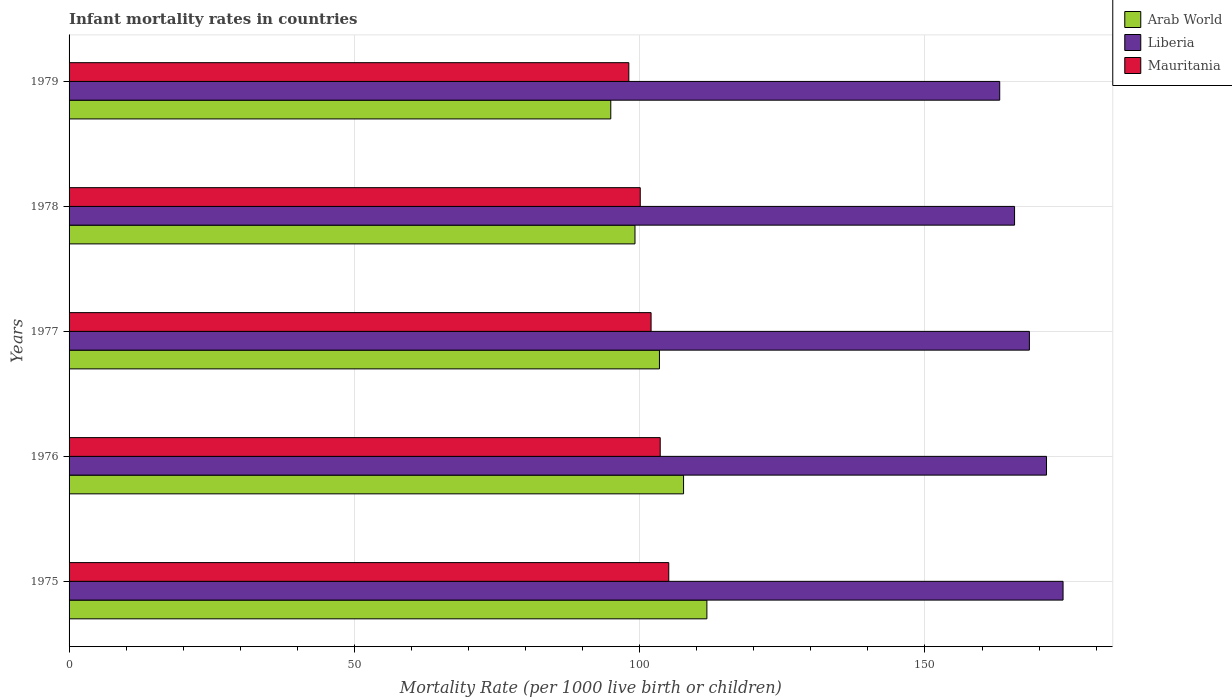How many groups of bars are there?
Keep it short and to the point. 5. Are the number of bars per tick equal to the number of legend labels?
Provide a short and direct response. Yes. What is the label of the 1st group of bars from the top?
Provide a short and direct response. 1979. In how many cases, is the number of bars for a given year not equal to the number of legend labels?
Your response must be concise. 0. What is the infant mortality rate in Arab World in 1979?
Give a very brief answer. 94.94. Across all years, what is the maximum infant mortality rate in Liberia?
Provide a short and direct response. 174.2. Across all years, what is the minimum infant mortality rate in Mauritania?
Ensure brevity in your answer.  98.1. In which year was the infant mortality rate in Mauritania maximum?
Give a very brief answer. 1975. In which year was the infant mortality rate in Arab World minimum?
Keep it short and to the point. 1979. What is the total infant mortality rate in Mauritania in the graph?
Make the answer very short. 508.9. What is the difference between the infant mortality rate in Mauritania in 1977 and that in 1978?
Provide a succinct answer. 1.9. What is the difference between the infant mortality rate in Liberia in 1977 and the infant mortality rate in Mauritania in 1976?
Provide a short and direct response. 64.7. What is the average infant mortality rate in Liberia per year?
Provide a short and direct response. 168.52. In the year 1977, what is the difference between the infant mortality rate in Mauritania and infant mortality rate in Liberia?
Offer a very short reply. -66.3. In how many years, is the infant mortality rate in Arab World greater than 170 ?
Provide a succinct answer. 0. What is the ratio of the infant mortality rate in Arab World in 1975 to that in 1978?
Provide a succinct answer. 1.13. What is the difference between the highest and the second highest infant mortality rate in Arab World?
Make the answer very short. 4.09. What is the difference between the highest and the lowest infant mortality rate in Liberia?
Provide a succinct answer. 11.1. Is the sum of the infant mortality rate in Liberia in 1975 and 1977 greater than the maximum infant mortality rate in Mauritania across all years?
Provide a succinct answer. Yes. What does the 2nd bar from the top in 1976 represents?
Your answer should be very brief. Liberia. What does the 1st bar from the bottom in 1979 represents?
Your response must be concise. Arab World. How many bars are there?
Offer a terse response. 15. What is the difference between two consecutive major ticks on the X-axis?
Provide a short and direct response. 50. Are the values on the major ticks of X-axis written in scientific E-notation?
Offer a very short reply. No. Does the graph contain any zero values?
Your answer should be compact. No. Does the graph contain grids?
Your answer should be very brief. Yes. What is the title of the graph?
Ensure brevity in your answer.  Infant mortality rates in countries. What is the label or title of the X-axis?
Provide a short and direct response. Mortality Rate (per 1000 live birth or children). What is the label or title of the Y-axis?
Provide a short and direct response. Years. What is the Mortality Rate (per 1000 live birth or children) in Arab World in 1975?
Offer a terse response. 111.78. What is the Mortality Rate (per 1000 live birth or children) of Liberia in 1975?
Ensure brevity in your answer.  174.2. What is the Mortality Rate (per 1000 live birth or children) in Mauritania in 1975?
Provide a succinct answer. 105.1. What is the Mortality Rate (per 1000 live birth or children) of Arab World in 1976?
Provide a succinct answer. 107.69. What is the Mortality Rate (per 1000 live birth or children) of Liberia in 1976?
Offer a terse response. 171.3. What is the Mortality Rate (per 1000 live birth or children) in Mauritania in 1976?
Your answer should be very brief. 103.6. What is the Mortality Rate (per 1000 live birth or children) of Arab World in 1977?
Ensure brevity in your answer.  103.47. What is the Mortality Rate (per 1000 live birth or children) of Liberia in 1977?
Make the answer very short. 168.3. What is the Mortality Rate (per 1000 live birth or children) of Mauritania in 1977?
Give a very brief answer. 102. What is the Mortality Rate (per 1000 live birth or children) in Arab World in 1978?
Keep it short and to the point. 99.18. What is the Mortality Rate (per 1000 live birth or children) in Liberia in 1978?
Give a very brief answer. 165.7. What is the Mortality Rate (per 1000 live birth or children) in Mauritania in 1978?
Provide a short and direct response. 100.1. What is the Mortality Rate (per 1000 live birth or children) in Arab World in 1979?
Make the answer very short. 94.94. What is the Mortality Rate (per 1000 live birth or children) of Liberia in 1979?
Offer a very short reply. 163.1. What is the Mortality Rate (per 1000 live birth or children) in Mauritania in 1979?
Make the answer very short. 98.1. Across all years, what is the maximum Mortality Rate (per 1000 live birth or children) of Arab World?
Give a very brief answer. 111.78. Across all years, what is the maximum Mortality Rate (per 1000 live birth or children) of Liberia?
Your answer should be compact. 174.2. Across all years, what is the maximum Mortality Rate (per 1000 live birth or children) of Mauritania?
Make the answer very short. 105.1. Across all years, what is the minimum Mortality Rate (per 1000 live birth or children) in Arab World?
Your response must be concise. 94.94. Across all years, what is the minimum Mortality Rate (per 1000 live birth or children) in Liberia?
Your response must be concise. 163.1. Across all years, what is the minimum Mortality Rate (per 1000 live birth or children) of Mauritania?
Keep it short and to the point. 98.1. What is the total Mortality Rate (per 1000 live birth or children) of Arab World in the graph?
Offer a terse response. 517.05. What is the total Mortality Rate (per 1000 live birth or children) in Liberia in the graph?
Provide a short and direct response. 842.6. What is the total Mortality Rate (per 1000 live birth or children) in Mauritania in the graph?
Offer a terse response. 508.9. What is the difference between the Mortality Rate (per 1000 live birth or children) in Arab World in 1975 and that in 1976?
Your answer should be compact. 4.09. What is the difference between the Mortality Rate (per 1000 live birth or children) of Mauritania in 1975 and that in 1976?
Offer a terse response. 1.5. What is the difference between the Mortality Rate (per 1000 live birth or children) in Arab World in 1975 and that in 1977?
Provide a short and direct response. 8.31. What is the difference between the Mortality Rate (per 1000 live birth or children) of Liberia in 1975 and that in 1977?
Your answer should be compact. 5.9. What is the difference between the Mortality Rate (per 1000 live birth or children) of Mauritania in 1975 and that in 1977?
Give a very brief answer. 3.1. What is the difference between the Mortality Rate (per 1000 live birth or children) in Arab World in 1975 and that in 1978?
Your response must be concise. 12.6. What is the difference between the Mortality Rate (per 1000 live birth or children) of Liberia in 1975 and that in 1978?
Provide a succinct answer. 8.5. What is the difference between the Mortality Rate (per 1000 live birth or children) in Mauritania in 1975 and that in 1978?
Provide a succinct answer. 5. What is the difference between the Mortality Rate (per 1000 live birth or children) in Arab World in 1975 and that in 1979?
Your answer should be very brief. 16.84. What is the difference between the Mortality Rate (per 1000 live birth or children) in Arab World in 1976 and that in 1977?
Provide a short and direct response. 4.23. What is the difference between the Mortality Rate (per 1000 live birth or children) in Liberia in 1976 and that in 1977?
Provide a succinct answer. 3. What is the difference between the Mortality Rate (per 1000 live birth or children) of Mauritania in 1976 and that in 1977?
Offer a terse response. 1.6. What is the difference between the Mortality Rate (per 1000 live birth or children) of Arab World in 1976 and that in 1978?
Make the answer very short. 8.51. What is the difference between the Mortality Rate (per 1000 live birth or children) in Liberia in 1976 and that in 1978?
Your answer should be very brief. 5.6. What is the difference between the Mortality Rate (per 1000 live birth or children) of Arab World in 1976 and that in 1979?
Keep it short and to the point. 12.76. What is the difference between the Mortality Rate (per 1000 live birth or children) of Liberia in 1976 and that in 1979?
Provide a short and direct response. 8.2. What is the difference between the Mortality Rate (per 1000 live birth or children) in Mauritania in 1976 and that in 1979?
Your answer should be compact. 5.5. What is the difference between the Mortality Rate (per 1000 live birth or children) of Arab World in 1977 and that in 1978?
Your answer should be very brief. 4.29. What is the difference between the Mortality Rate (per 1000 live birth or children) of Arab World in 1977 and that in 1979?
Your answer should be compact. 8.53. What is the difference between the Mortality Rate (per 1000 live birth or children) of Liberia in 1977 and that in 1979?
Your answer should be compact. 5.2. What is the difference between the Mortality Rate (per 1000 live birth or children) in Arab World in 1978 and that in 1979?
Make the answer very short. 4.24. What is the difference between the Mortality Rate (per 1000 live birth or children) of Liberia in 1978 and that in 1979?
Your response must be concise. 2.6. What is the difference between the Mortality Rate (per 1000 live birth or children) of Mauritania in 1978 and that in 1979?
Ensure brevity in your answer.  2. What is the difference between the Mortality Rate (per 1000 live birth or children) in Arab World in 1975 and the Mortality Rate (per 1000 live birth or children) in Liberia in 1976?
Your response must be concise. -59.52. What is the difference between the Mortality Rate (per 1000 live birth or children) in Arab World in 1975 and the Mortality Rate (per 1000 live birth or children) in Mauritania in 1976?
Keep it short and to the point. 8.18. What is the difference between the Mortality Rate (per 1000 live birth or children) in Liberia in 1975 and the Mortality Rate (per 1000 live birth or children) in Mauritania in 1976?
Offer a very short reply. 70.6. What is the difference between the Mortality Rate (per 1000 live birth or children) of Arab World in 1975 and the Mortality Rate (per 1000 live birth or children) of Liberia in 1977?
Provide a short and direct response. -56.52. What is the difference between the Mortality Rate (per 1000 live birth or children) of Arab World in 1975 and the Mortality Rate (per 1000 live birth or children) of Mauritania in 1977?
Offer a very short reply. 9.78. What is the difference between the Mortality Rate (per 1000 live birth or children) of Liberia in 1975 and the Mortality Rate (per 1000 live birth or children) of Mauritania in 1977?
Your answer should be compact. 72.2. What is the difference between the Mortality Rate (per 1000 live birth or children) in Arab World in 1975 and the Mortality Rate (per 1000 live birth or children) in Liberia in 1978?
Provide a short and direct response. -53.92. What is the difference between the Mortality Rate (per 1000 live birth or children) of Arab World in 1975 and the Mortality Rate (per 1000 live birth or children) of Mauritania in 1978?
Ensure brevity in your answer.  11.68. What is the difference between the Mortality Rate (per 1000 live birth or children) of Liberia in 1975 and the Mortality Rate (per 1000 live birth or children) of Mauritania in 1978?
Your response must be concise. 74.1. What is the difference between the Mortality Rate (per 1000 live birth or children) of Arab World in 1975 and the Mortality Rate (per 1000 live birth or children) of Liberia in 1979?
Ensure brevity in your answer.  -51.32. What is the difference between the Mortality Rate (per 1000 live birth or children) of Arab World in 1975 and the Mortality Rate (per 1000 live birth or children) of Mauritania in 1979?
Offer a terse response. 13.68. What is the difference between the Mortality Rate (per 1000 live birth or children) of Liberia in 1975 and the Mortality Rate (per 1000 live birth or children) of Mauritania in 1979?
Offer a very short reply. 76.1. What is the difference between the Mortality Rate (per 1000 live birth or children) of Arab World in 1976 and the Mortality Rate (per 1000 live birth or children) of Liberia in 1977?
Offer a very short reply. -60.61. What is the difference between the Mortality Rate (per 1000 live birth or children) of Arab World in 1976 and the Mortality Rate (per 1000 live birth or children) of Mauritania in 1977?
Provide a short and direct response. 5.69. What is the difference between the Mortality Rate (per 1000 live birth or children) of Liberia in 1976 and the Mortality Rate (per 1000 live birth or children) of Mauritania in 1977?
Provide a short and direct response. 69.3. What is the difference between the Mortality Rate (per 1000 live birth or children) in Arab World in 1976 and the Mortality Rate (per 1000 live birth or children) in Liberia in 1978?
Make the answer very short. -58.01. What is the difference between the Mortality Rate (per 1000 live birth or children) of Arab World in 1976 and the Mortality Rate (per 1000 live birth or children) of Mauritania in 1978?
Ensure brevity in your answer.  7.59. What is the difference between the Mortality Rate (per 1000 live birth or children) in Liberia in 1976 and the Mortality Rate (per 1000 live birth or children) in Mauritania in 1978?
Keep it short and to the point. 71.2. What is the difference between the Mortality Rate (per 1000 live birth or children) of Arab World in 1976 and the Mortality Rate (per 1000 live birth or children) of Liberia in 1979?
Ensure brevity in your answer.  -55.41. What is the difference between the Mortality Rate (per 1000 live birth or children) of Arab World in 1976 and the Mortality Rate (per 1000 live birth or children) of Mauritania in 1979?
Your answer should be compact. 9.59. What is the difference between the Mortality Rate (per 1000 live birth or children) in Liberia in 1976 and the Mortality Rate (per 1000 live birth or children) in Mauritania in 1979?
Your answer should be very brief. 73.2. What is the difference between the Mortality Rate (per 1000 live birth or children) of Arab World in 1977 and the Mortality Rate (per 1000 live birth or children) of Liberia in 1978?
Provide a succinct answer. -62.23. What is the difference between the Mortality Rate (per 1000 live birth or children) in Arab World in 1977 and the Mortality Rate (per 1000 live birth or children) in Mauritania in 1978?
Make the answer very short. 3.37. What is the difference between the Mortality Rate (per 1000 live birth or children) in Liberia in 1977 and the Mortality Rate (per 1000 live birth or children) in Mauritania in 1978?
Provide a succinct answer. 68.2. What is the difference between the Mortality Rate (per 1000 live birth or children) in Arab World in 1977 and the Mortality Rate (per 1000 live birth or children) in Liberia in 1979?
Offer a terse response. -59.63. What is the difference between the Mortality Rate (per 1000 live birth or children) of Arab World in 1977 and the Mortality Rate (per 1000 live birth or children) of Mauritania in 1979?
Ensure brevity in your answer.  5.37. What is the difference between the Mortality Rate (per 1000 live birth or children) of Liberia in 1977 and the Mortality Rate (per 1000 live birth or children) of Mauritania in 1979?
Give a very brief answer. 70.2. What is the difference between the Mortality Rate (per 1000 live birth or children) in Arab World in 1978 and the Mortality Rate (per 1000 live birth or children) in Liberia in 1979?
Offer a terse response. -63.92. What is the difference between the Mortality Rate (per 1000 live birth or children) in Arab World in 1978 and the Mortality Rate (per 1000 live birth or children) in Mauritania in 1979?
Your answer should be compact. 1.08. What is the difference between the Mortality Rate (per 1000 live birth or children) in Liberia in 1978 and the Mortality Rate (per 1000 live birth or children) in Mauritania in 1979?
Your answer should be very brief. 67.6. What is the average Mortality Rate (per 1000 live birth or children) in Arab World per year?
Your answer should be compact. 103.41. What is the average Mortality Rate (per 1000 live birth or children) of Liberia per year?
Provide a succinct answer. 168.52. What is the average Mortality Rate (per 1000 live birth or children) of Mauritania per year?
Keep it short and to the point. 101.78. In the year 1975, what is the difference between the Mortality Rate (per 1000 live birth or children) in Arab World and Mortality Rate (per 1000 live birth or children) in Liberia?
Offer a terse response. -62.42. In the year 1975, what is the difference between the Mortality Rate (per 1000 live birth or children) in Arab World and Mortality Rate (per 1000 live birth or children) in Mauritania?
Keep it short and to the point. 6.68. In the year 1975, what is the difference between the Mortality Rate (per 1000 live birth or children) in Liberia and Mortality Rate (per 1000 live birth or children) in Mauritania?
Offer a terse response. 69.1. In the year 1976, what is the difference between the Mortality Rate (per 1000 live birth or children) of Arab World and Mortality Rate (per 1000 live birth or children) of Liberia?
Give a very brief answer. -63.61. In the year 1976, what is the difference between the Mortality Rate (per 1000 live birth or children) in Arab World and Mortality Rate (per 1000 live birth or children) in Mauritania?
Provide a succinct answer. 4.09. In the year 1976, what is the difference between the Mortality Rate (per 1000 live birth or children) of Liberia and Mortality Rate (per 1000 live birth or children) of Mauritania?
Keep it short and to the point. 67.7. In the year 1977, what is the difference between the Mortality Rate (per 1000 live birth or children) of Arab World and Mortality Rate (per 1000 live birth or children) of Liberia?
Give a very brief answer. -64.83. In the year 1977, what is the difference between the Mortality Rate (per 1000 live birth or children) of Arab World and Mortality Rate (per 1000 live birth or children) of Mauritania?
Your response must be concise. 1.47. In the year 1977, what is the difference between the Mortality Rate (per 1000 live birth or children) of Liberia and Mortality Rate (per 1000 live birth or children) of Mauritania?
Offer a terse response. 66.3. In the year 1978, what is the difference between the Mortality Rate (per 1000 live birth or children) in Arab World and Mortality Rate (per 1000 live birth or children) in Liberia?
Keep it short and to the point. -66.52. In the year 1978, what is the difference between the Mortality Rate (per 1000 live birth or children) in Arab World and Mortality Rate (per 1000 live birth or children) in Mauritania?
Ensure brevity in your answer.  -0.92. In the year 1978, what is the difference between the Mortality Rate (per 1000 live birth or children) in Liberia and Mortality Rate (per 1000 live birth or children) in Mauritania?
Ensure brevity in your answer.  65.6. In the year 1979, what is the difference between the Mortality Rate (per 1000 live birth or children) of Arab World and Mortality Rate (per 1000 live birth or children) of Liberia?
Offer a terse response. -68.16. In the year 1979, what is the difference between the Mortality Rate (per 1000 live birth or children) in Arab World and Mortality Rate (per 1000 live birth or children) in Mauritania?
Your answer should be very brief. -3.16. What is the ratio of the Mortality Rate (per 1000 live birth or children) of Arab World in 1975 to that in 1976?
Your answer should be compact. 1.04. What is the ratio of the Mortality Rate (per 1000 live birth or children) in Liberia in 1975 to that in 1976?
Ensure brevity in your answer.  1.02. What is the ratio of the Mortality Rate (per 1000 live birth or children) of Mauritania in 1975 to that in 1976?
Offer a very short reply. 1.01. What is the ratio of the Mortality Rate (per 1000 live birth or children) of Arab World in 1975 to that in 1977?
Your answer should be very brief. 1.08. What is the ratio of the Mortality Rate (per 1000 live birth or children) of Liberia in 1975 to that in 1977?
Offer a terse response. 1.04. What is the ratio of the Mortality Rate (per 1000 live birth or children) of Mauritania in 1975 to that in 1977?
Your response must be concise. 1.03. What is the ratio of the Mortality Rate (per 1000 live birth or children) in Arab World in 1975 to that in 1978?
Your answer should be very brief. 1.13. What is the ratio of the Mortality Rate (per 1000 live birth or children) in Liberia in 1975 to that in 1978?
Your answer should be compact. 1.05. What is the ratio of the Mortality Rate (per 1000 live birth or children) in Arab World in 1975 to that in 1979?
Your answer should be very brief. 1.18. What is the ratio of the Mortality Rate (per 1000 live birth or children) in Liberia in 1975 to that in 1979?
Ensure brevity in your answer.  1.07. What is the ratio of the Mortality Rate (per 1000 live birth or children) of Mauritania in 1975 to that in 1979?
Offer a very short reply. 1.07. What is the ratio of the Mortality Rate (per 1000 live birth or children) in Arab World in 1976 to that in 1977?
Your answer should be very brief. 1.04. What is the ratio of the Mortality Rate (per 1000 live birth or children) of Liberia in 1976 to that in 1977?
Offer a terse response. 1.02. What is the ratio of the Mortality Rate (per 1000 live birth or children) of Mauritania in 1976 to that in 1977?
Your response must be concise. 1.02. What is the ratio of the Mortality Rate (per 1000 live birth or children) in Arab World in 1976 to that in 1978?
Offer a very short reply. 1.09. What is the ratio of the Mortality Rate (per 1000 live birth or children) of Liberia in 1976 to that in 1978?
Offer a terse response. 1.03. What is the ratio of the Mortality Rate (per 1000 live birth or children) in Mauritania in 1976 to that in 1978?
Give a very brief answer. 1.03. What is the ratio of the Mortality Rate (per 1000 live birth or children) in Arab World in 1976 to that in 1979?
Keep it short and to the point. 1.13. What is the ratio of the Mortality Rate (per 1000 live birth or children) of Liberia in 1976 to that in 1979?
Give a very brief answer. 1.05. What is the ratio of the Mortality Rate (per 1000 live birth or children) of Mauritania in 1976 to that in 1979?
Offer a terse response. 1.06. What is the ratio of the Mortality Rate (per 1000 live birth or children) in Arab World in 1977 to that in 1978?
Offer a very short reply. 1.04. What is the ratio of the Mortality Rate (per 1000 live birth or children) of Liberia in 1977 to that in 1978?
Offer a terse response. 1.02. What is the ratio of the Mortality Rate (per 1000 live birth or children) in Mauritania in 1977 to that in 1978?
Ensure brevity in your answer.  1.02. What is the ratio of the Mortality Rate (per 1000 live birth or children) in Arab World in 1977 to that in 1979?
Offer a terse response. 1.09. What is the ratio of the Mortality Rate (per 1000 live birth or children) in Liberia in 1977 to that in 1979?
Your answer should be compact. 1.03. What is the ratio of the Mortality Rate (per 1000 live birth or children) in Mauritania in 1977 to that in 1979?
Your answer should be compact. 1.04. What is the ratio of the Mortality Rate (per 1000 live birth or children) in Arab World in 1978 to that in 1979?
Keep it short and to the point. 1.04. What is the ratio of the Mortality Rate (per 1000 live birth or children) of Liberia in 1978 to that in 1979?
Your answer should be very brief. 1.02. What is the ratio of the Mortality Rate (per 1000 live birth or children) of Mauritania in 1978 to that in 1979?
Offer a very short reply. 1.02. What is the difference between the highest and the second highest Mortality Rate (per 1000 live birth or children) in Arab World?
Give a very brief answer. 4.09. What is the difference between the highest and the second highest Mortality Rate (per 1000 live birth or children) of Mauritania?
Give a very brief answer. 1.5. What is the difference between the highest and the lowest Mortality Rate (per 1000 live birth or children) of Arab World?
Ensure brevity in your answer.  16.84. 